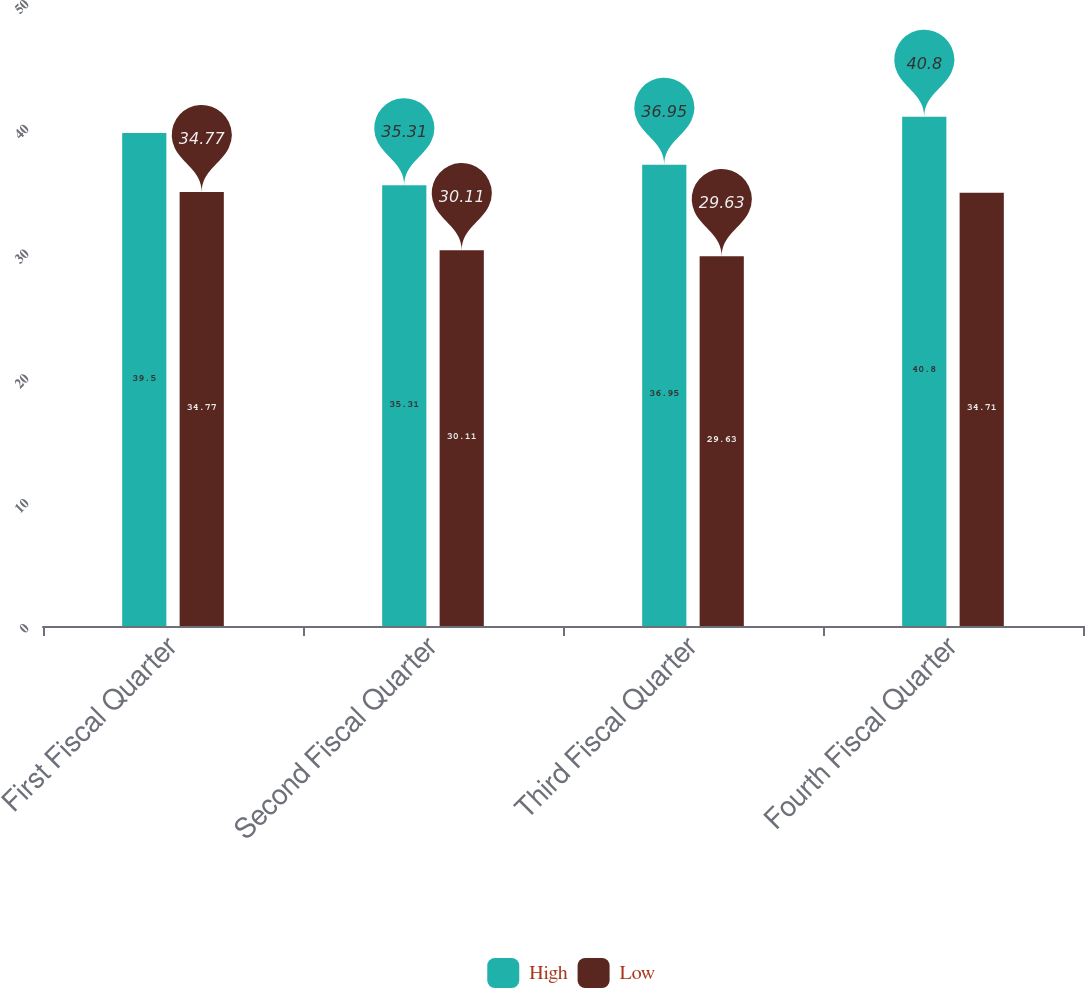Convert chart. <chart><loc_0><loc_0><loc_500><loc_500><stacked_bar_chart><ecel><fcel>First Fiscal Quarter<fcel>Second Fiscal Quarter<fcel>Third Fiscal Quarter<fcel>Fourth Fiscal Quarter<nl><fcel>High<fcel>39.5<fcel>35.31<fcel>36.95<fcel>40.8<nl><fcel>Low<fcel>34.77<fcel>30.11<fcel>29.63<fcel>34.71<nl></chart> 